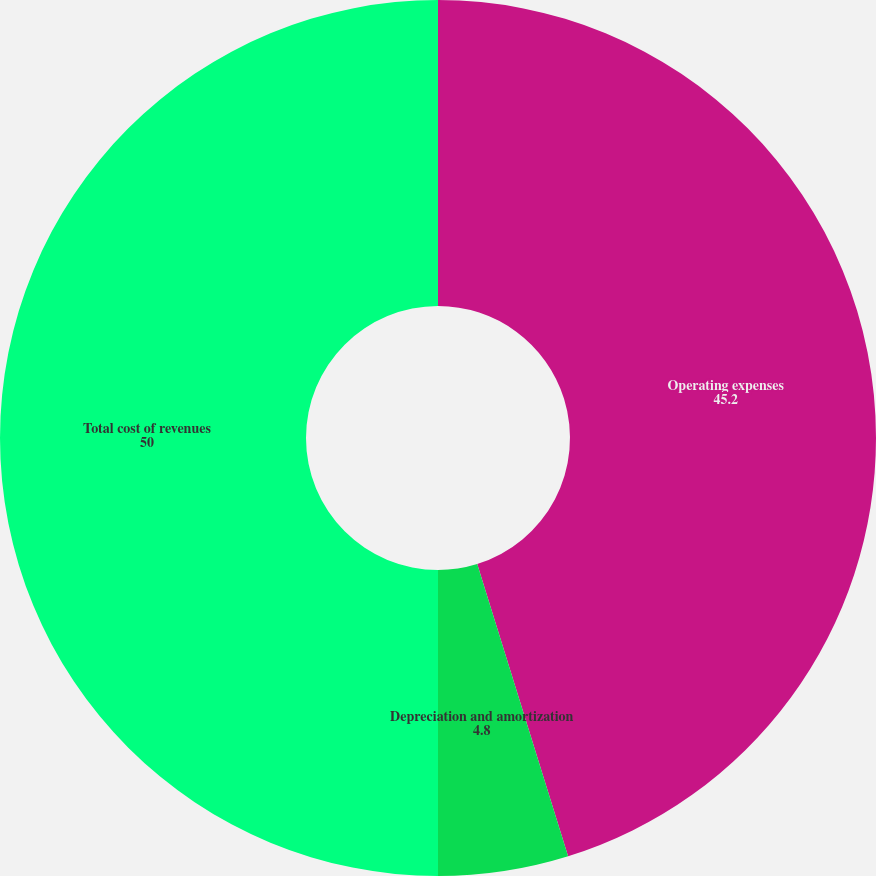Convert chart to OTSL. <chart><loc_0><loc_0><loc_500><loc_500><pie_chart><fcel>Operating expenses<fcel>Depreciation and amortization<fcel>Total cost of revenues<nl><fcel>45.2%<fcel>4.8%<fcel>50.0%<nl></chart> 